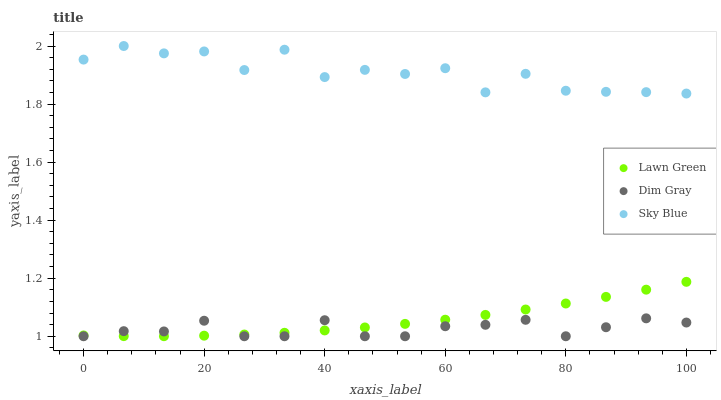Does Dim Gray have the minimum area under the curve?
Answer yes or no. Yes. Does Sky Blue have the maximum area under the curve?
Answer yes or no. Yes. Does Sky Blue have the minimum area under the curve?
Answer yes or no. No. Does Dim Gray have the maximum area under the curve?
Answer yes or no. No. Is Lawn Green the smoothest?
Answer yes or no. Yes. Is Sky Blue the roughest?
Answer yes or no. Yes. Is Dim Gray the smoothest?
Answer yes or no. No. Is Dim Gray the roughest?
Answer yes or no. No. Does Dim Gray have the lowest value?
Answer yes or no. Yes. Does Sky Blue have the lowest value?
Answer yes or no. No. Does Sky Blue have the highest value?
Answer yes or no. Yes. Does Dim Gray have the highest value?
Answer yes or no. No. Is Dim Gray less than Sky Blue?
Answer yes or no. Yes. Is Sky Blue greater than Dim Gray?
Answer yes or no. Yes. Does Dim Gray intersect Lawn Green?
Answer yes or no. Yes. Is Dim Gray less than Lawn Green?
Answer yes or no. No. Is Dim Gray greater than Lawn Green?
Answer yes or no. No. Does Dim Gray intersect Sky Blue?
Answer yes or no. No. 